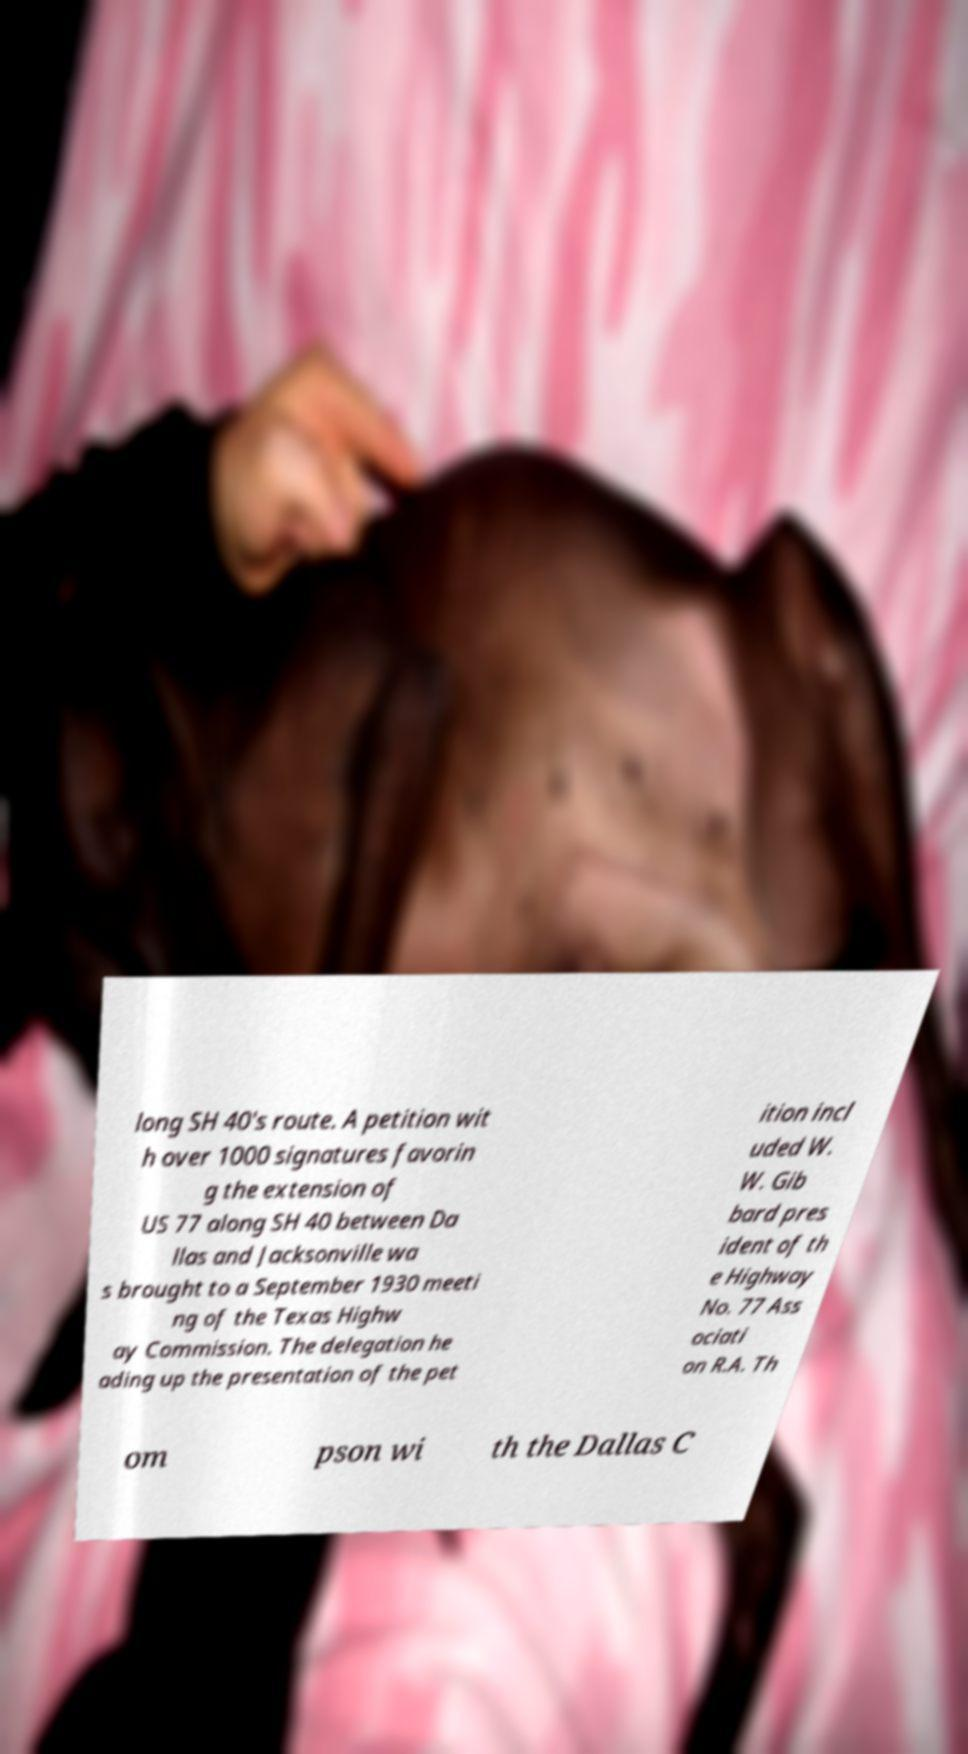Can you accurately transcribe the text from the provided image for me? long SH 40's route. A petition wit h over 1000 signatures favorin g the extension of US 77 along SH 40 between Da llas and Jacksonville wa s brought to a September 1930 meeti ng of the Texas Highw ay Commission. The delegation he ading up the presentation of the pet ition incl uded W. W. Gib bard pres ident of th e Highway No. 77 Ass ociati on R.A. Th om pson wi th the Dallas C 